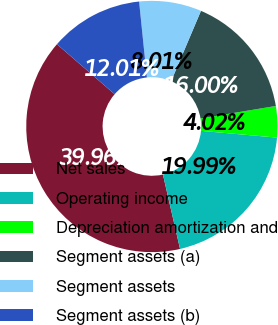Convert chart to OTSL. <chart><loc_0><loc_0><loc_500><loc_500><pie_chart><fcel>Net sales<fcel>Operating income<fcel>Depreciation amortization and<fcel>Segment assets (a)<fcel>Segment assets<fcel>Segment assets (b)<nl><fcel>39.96%<fcel>19.99%<fcel>4.02%<fcel>16.0%<fcel>8.01%<fcel>12.01%<nl></chart> 